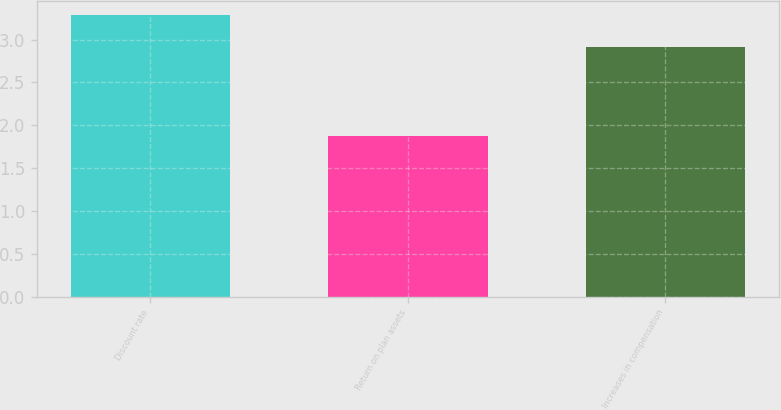<chart> <loc_0><loc_0><loc_500><loc_500><bar_chart><fcel>Discount rate<fcel>Return on plan assets<fcel>Increases in compensation<nl><fcel>3.29<fcel>1.88<fcel>2.91<nl></chart> 